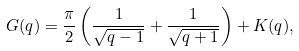<formula> <loc_0><loc_0><loc_500><loc_500>G ( q ) = \frac { \pi } { 2 } \left ( \frac { 1 } { \sqrt { q - 1 } } + \frac { 1 } { \sqrt { q + 1 } } \right ) + K ( q ) ,</formula> 